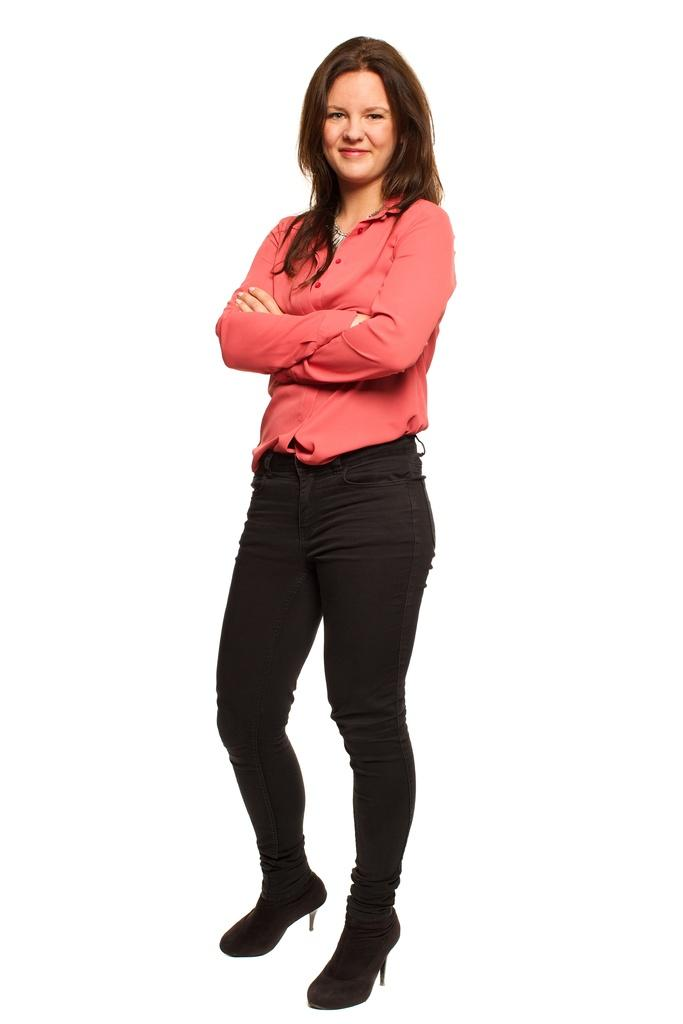Who is present in the image? There is a woman in the image. What is the woman doing in the image? The woman is standing in the image. What is the woman's facial expression in the image? The woman is smiling in the image. What type of farm animals can be seen in the image? There are no farm animals present in the image; it features a woman standing and smiling. 